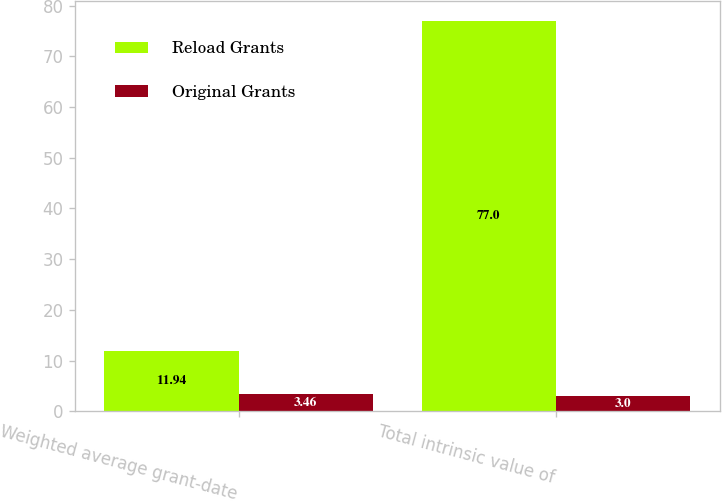Convert chart to OTSL. <chart><loc_0><loc_0><loc_500><loc_500><stacked_bar_chart><ecel><fcel>Weighted average grant-date<fcel>Total intrinsic value of<nl><fcel>Reload Grants<fcel>11.94<fcel>77<nl><fcel>Original Grants<fcel>3.46<fcel>3<nl></chart> 